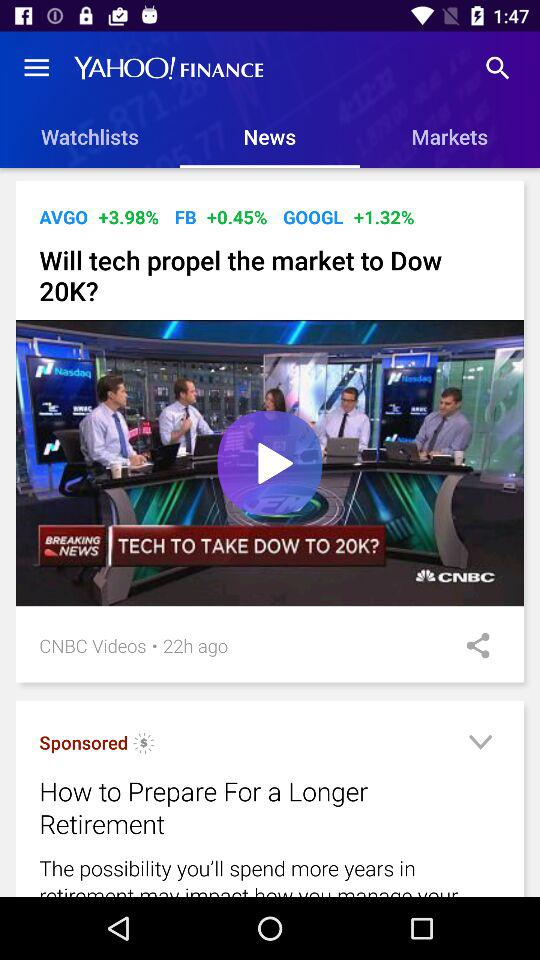How many hours ago did CNBC upload the video? CNBC uploaded the video 22 hours ago. 